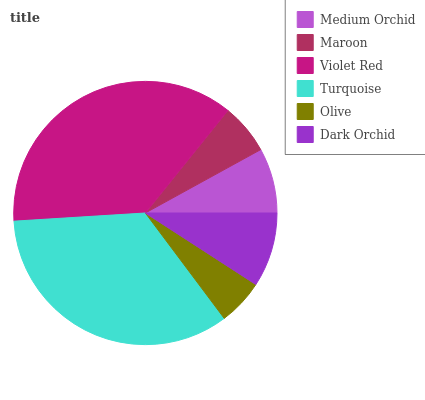Is Olive the minimum?
Answer yes or no. Yes. Is Violet Red the maximum?
Answer yes or no. Yes. Is Maroon the minimum?
Answer yes or no. No. Is Maroon the maximum?
Answer yes or no. No. Is Medium Orchid greater than Maroon?
Answer yes or no. Yes. Is Maroon less than Medium Orchid?
Answer yes or no. Yes. Is Maroon greater than Medium Orchid?
Answer yes or no. No. Is Medium Orchid less than Maroon?
Answer yes or no. No. Is Dark Orchid the high median?
Answer yes or no. Yes. Is Medium Orchid the low median?
Answer yes or no. Yes. Is Violet Red the high median?
Answer yes or no. No. Is Violet Red the low median?
Answer yes or no. No. 